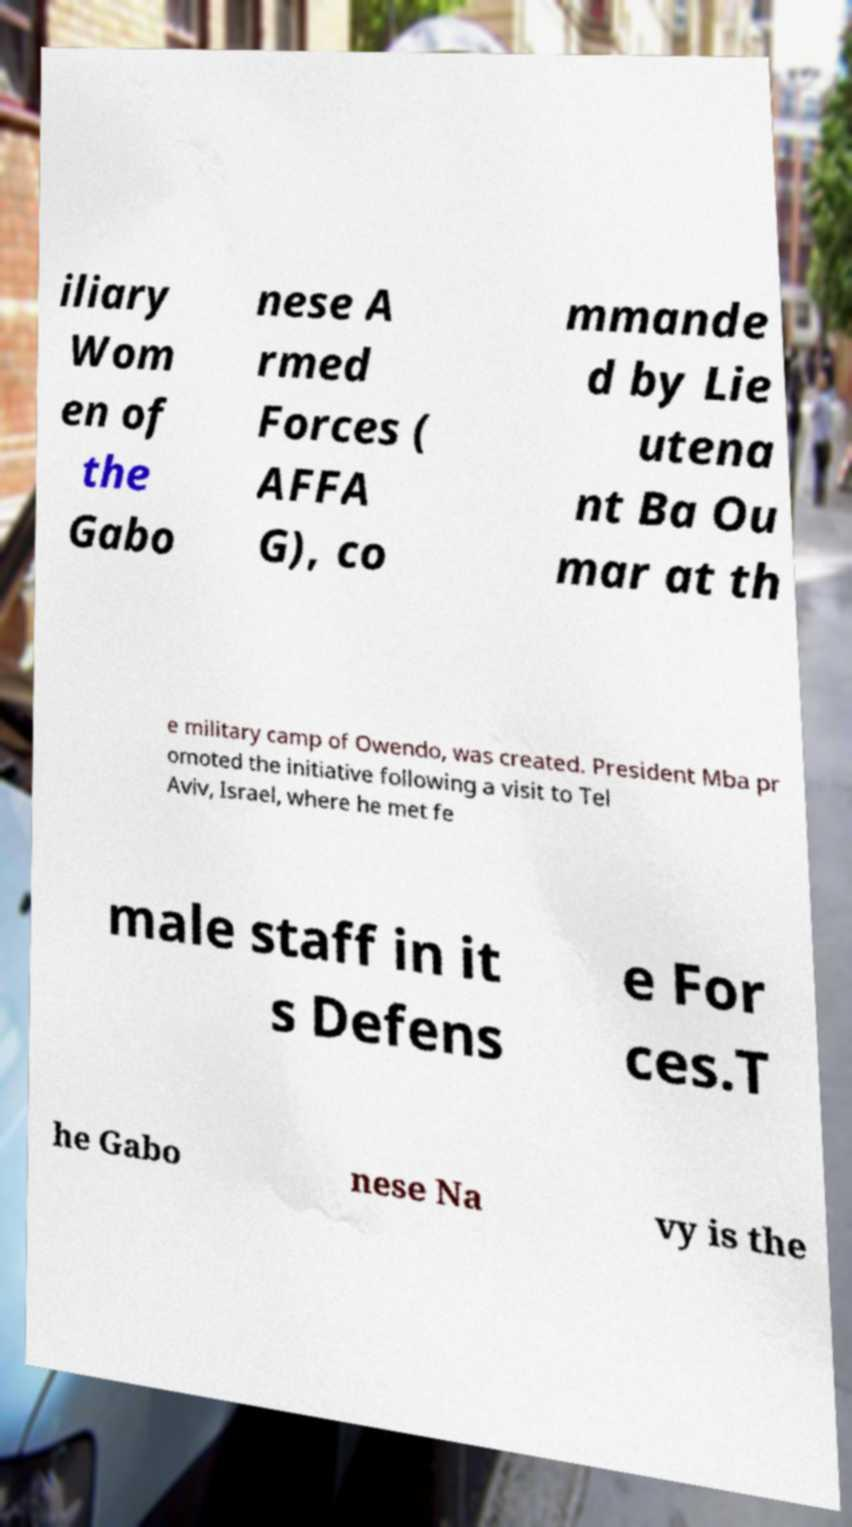Could you extract and type out the text from this image? iliary Wom en of the Gabo nese A rmed Forces ( AFFA G), co mmande d by Lie utena nt Ba Ou mar at th e military camp of Owendo, was created. President Mba pr omoted the initiative following a visit to Tel Aviv, Israel, where he met fe male staff in it s Defens e For ces.T he Gabo nese Na vy is the 